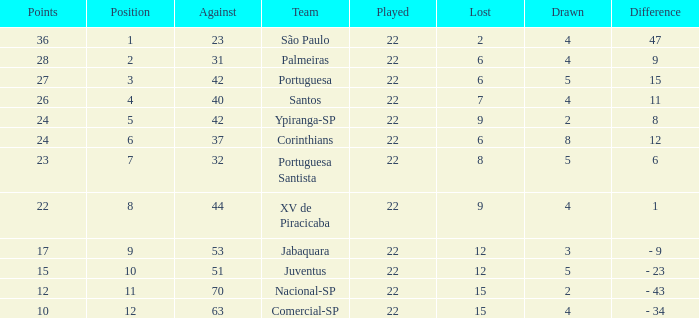Which Against has a Drawn smaller than 5, and a Lost smaller than 6, and a Points larger than 36? 0.0. I'm looking to parse the entire table for insights. Could you assist me with that? {'header': ['Points', 'Position', 'Against', 'Team', 'Played', 'Lost', 'Drawn', 'Difference'], 'rows': [['36', '1', '23', 'São Paulo', '22', '2', '4', '47'], ['28', '2', '31', 'Palmeiras', '22', '6', '4', '9'], ['27', '3', '42', 'Portuguesa', '22', '6', '5', '15'], ['26', '4', '40', 'Santos', '22', '7', '4', '11'], ['24', '5', '42', 'Ypiranga-SP', '22', '9', '2', '8'], ['24', '6', '37', 'Corinthians', '22', '6', '8', '12'], ['23', '7', '32', 'Portuguesa Santista', '22', '8', '5', '6'], ['22', '8', '44', 'XV de Piracicaba', '22', '9', '4', '1'], ['17', '9', '53', 'Jabaquara', '22', '12', '3', '- 9'], ['15', '10', '51', 'Juventus', '22', '12', '5', '- 23'], ['12', '11', '70', 'Nacional-SP', '22', '15', '2', '- 43'], ['10', '12', '63', 'Comercial-SP', '22', '15', '4', '- 34']]} 